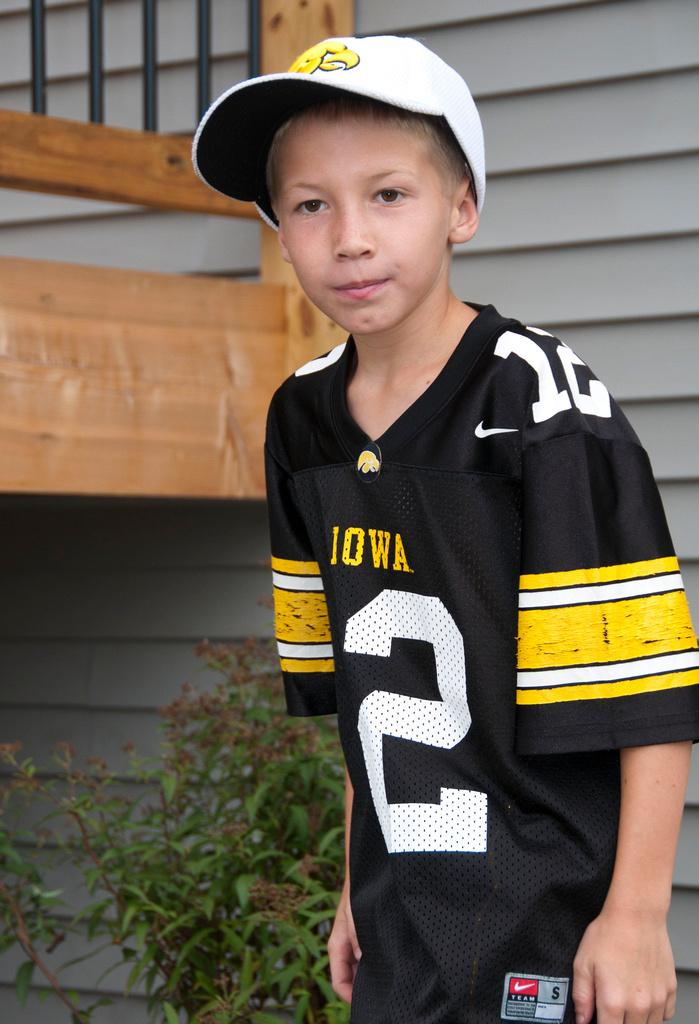Who is the main subject in the image? There is a small boy in the image. What is located behind the boy? There is a plant behind the boy. What can be seen in the background of the image? There is a wooden boundary in the background of the image. What type of pipe is the boy holding in the image? There is no pipe present in the image; the boy is not holding anything. 